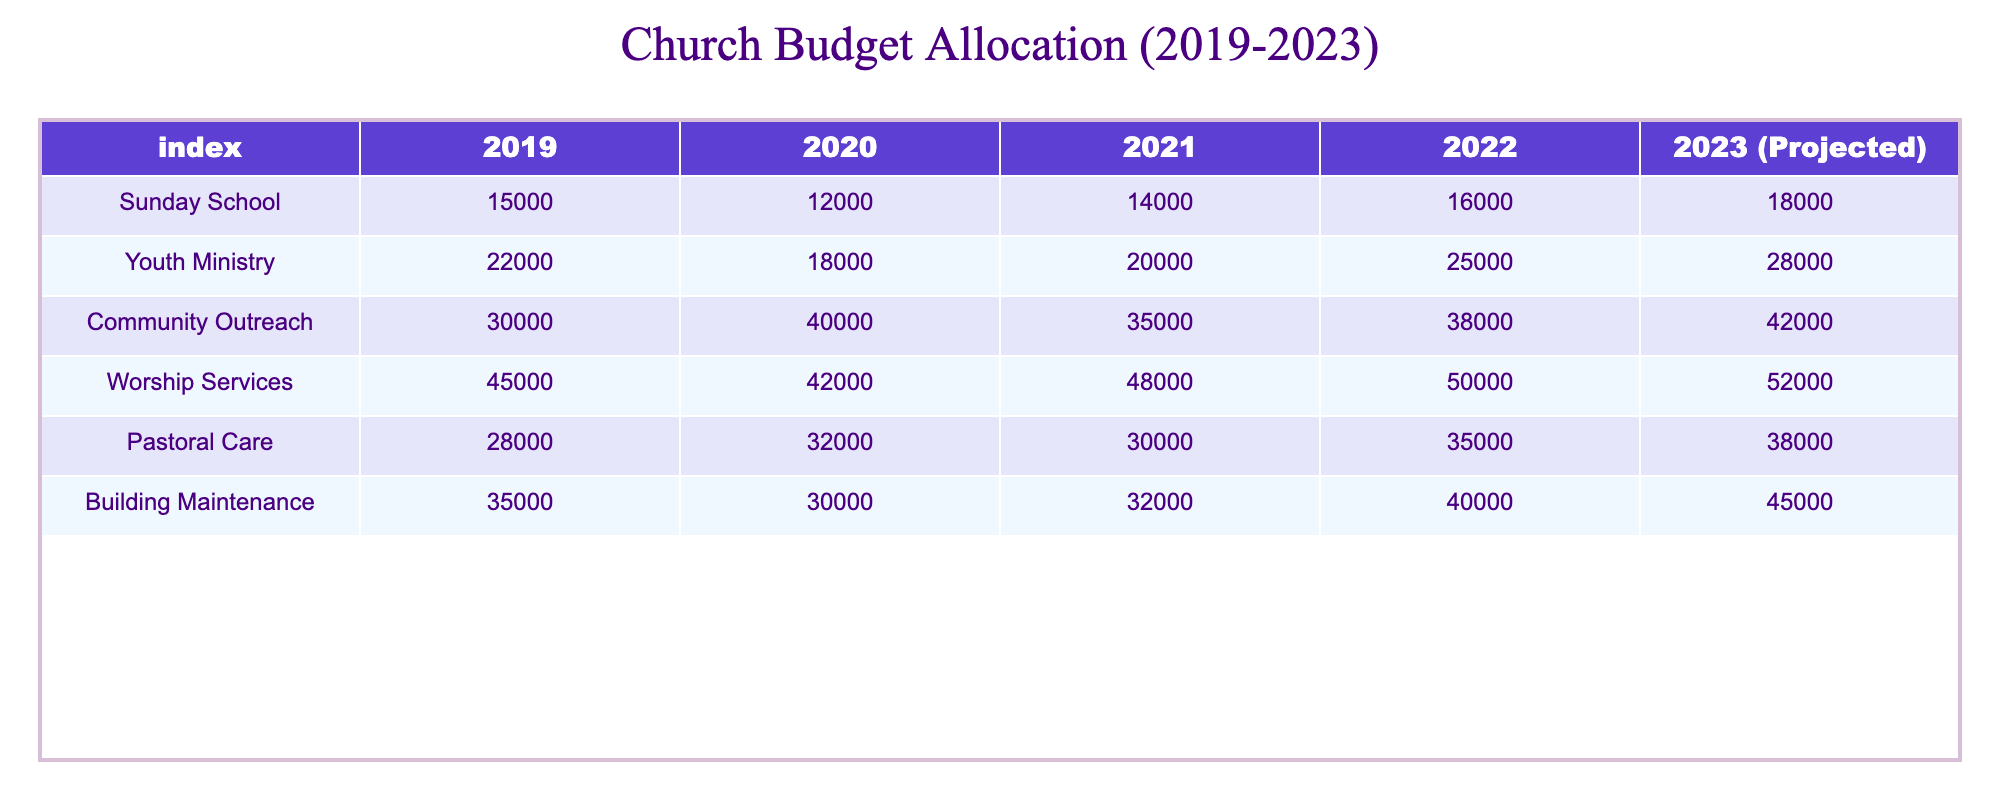What was the budget for Worship Services in 2021? The table shows that in 2021, the budget for Worship Services is listed as 48,000.
Answer: 48,000 How much more was allocated to Youth Ministry in 2022 than in 2019? The budget for Youth Ministry in 2022 is 25,000, and in 2019 it was 22,000. The difference is 25,000 - 22,000 = 3,000.
Answer: 3,000 What was the total budget allocation for Community Outreach from 2019 to 2023? We sum the values: 30,000 (2019) + 40,000 (2020) + 35,000 (2021) + 38,000 (2022) + 42,000 (2023 projected) = 185,000.
Answer: 185,000 Is the budget for Building Maintenance in 2020 higher than that for Pastoral Care in 2022? The budget for Building Maintenance in 2020 is 30,000, while for Pastoral Care in 2022 it is 35,000. Since 30,000 is less than 35,000, the answer is no.
Answer: No What was the percentage increase in the budget for Sunday School from 2019 to the projected budget in 2023? The budget for Sunday School in 2019 was 15,000 and the projected budget for 2023 is 18,000. The increase is 18,000 - 15,000 = 3,000. To find the percentage increase, use the formula (increase/original) * 100, which gives (3,000/15,000) * 100 = 20%.
Answer: 20% How does the total budget for 2023 compare to the total budget for 2019? First, calculate the total budget for 2023: 18,000 + 28,000 + 42,000 + 52,000 + 38,000 + 45,000 = 223,000. For 2019: 15,000 + 22,000 + 30,000 + 45,000 + 28,000 + 35,000 = 175,000. Since 223,000 is greater than 175,000, it shows an increase.
Answer: It shows an increase Was the budget allocation for Youth Ministry in any year less than 20,000? According to the table, the Youth Ministry budget for 2019 (22,000) and all subsequent years are above 20,000; thus, there are no years where the budget was less than 20,000.
Answer: No In which year did the Community Outreach budget experience its highest increase compared to the previous year? Triaging the values of Community Outreach: 30,000 (2019) to 40,000 (2020) is an increase of 10,000, 40,000 (2020) to 35,000 (2021) is a decrease, 35,000 (2021) to 38,000 (2022) is an increase of 3,000, and 38,000 (2022) to 42,000 (2023) is an increase of 4,000. The highest increase is 10,000 from 2019 to 2020.
Answer: 2019 to 2020 What is the difference in the total budget between Worship Services and Pastoral Care in 2022? For Worship Services, the budget in 2022 is 50,000, and for Pastoral Care, it is 35,000. The difference is 50,000 - 35,000 = 15,000.
Answer: 15,000 